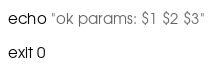Convert code to text. <code><loc_0><loc_0><loc_500><loc_500><_Bash_>
echo "ok params: $1 $2 $3" 

exit 0</code> 